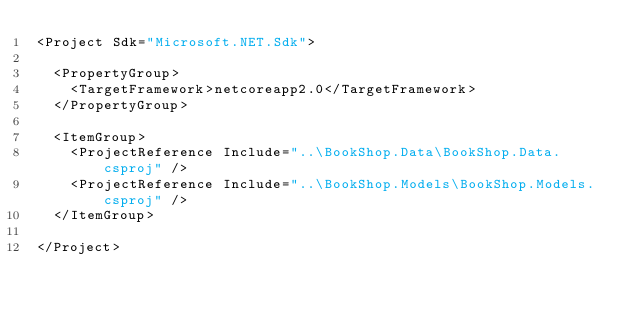<code> <loc_0><loc_0><loc_500><loc_500><_XML_><Project Sdk="Microsoft.NET.Sdk">

  <PropertyGroup>
    <TargetFramework>netcoreapp2.0</TargetFramework>
  </PropertyGroup>

  <ItemGroup>
    <ProjectReference Include="..\BookShop.Data\BookShop.Data.csproj" />
    <ProjectReference Include="..\BookShop.Models\BookShop.Models.csproj" />
  </ItemGroup>

</Project>
</code> 